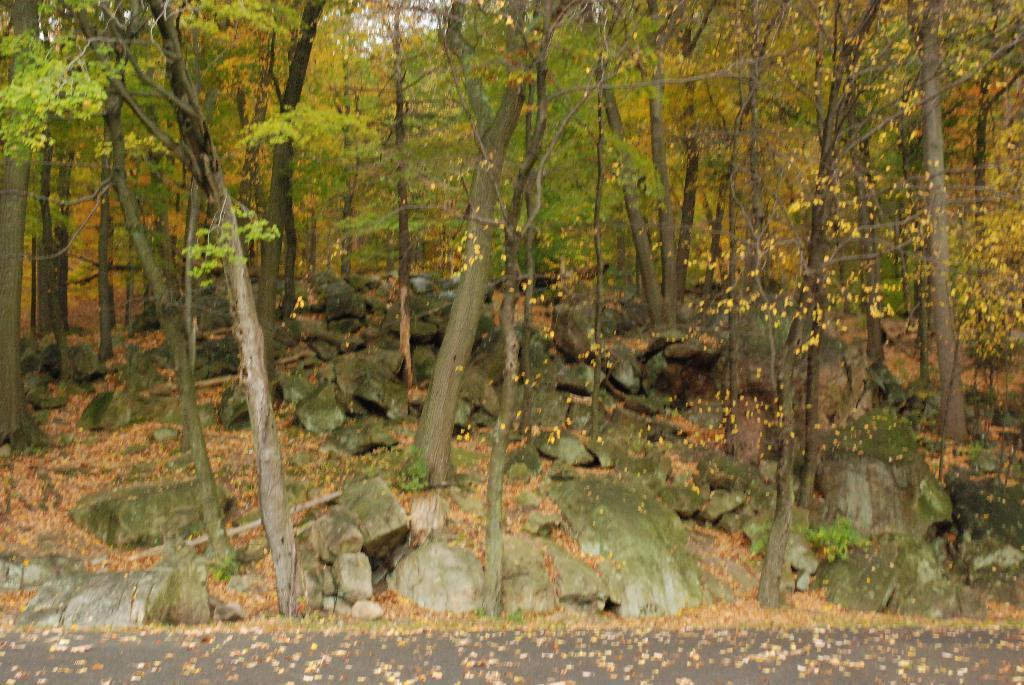What type of vegetation can be seen in the image? There are trees in the image. What can be found on the ground in the image? There are rocks and leaves visible on the ground in the image. What type of bead is used to decorate the trees in the image? There are no beads present in the image; the trees are not decorated with any beads. 